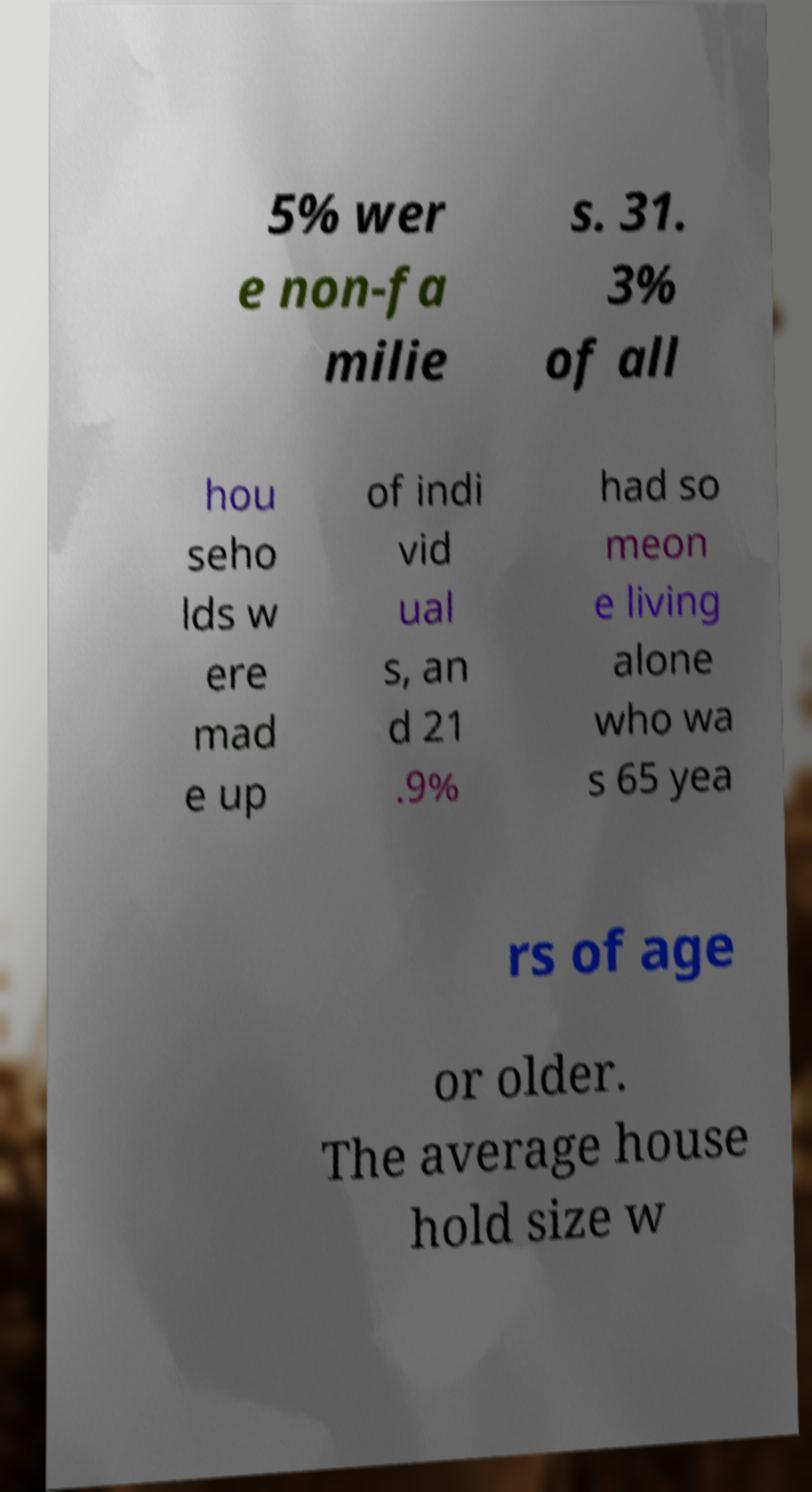I need the written content from this picture converted into text. Can you do that? 5% wer e non-fa milie s. 31. 3% of all hou seho lds w ere mad e up of indi vid ual s, an d 21 .9% had so meon e living alone who wa s 65 yea rs of age or older. The average house hold size w 